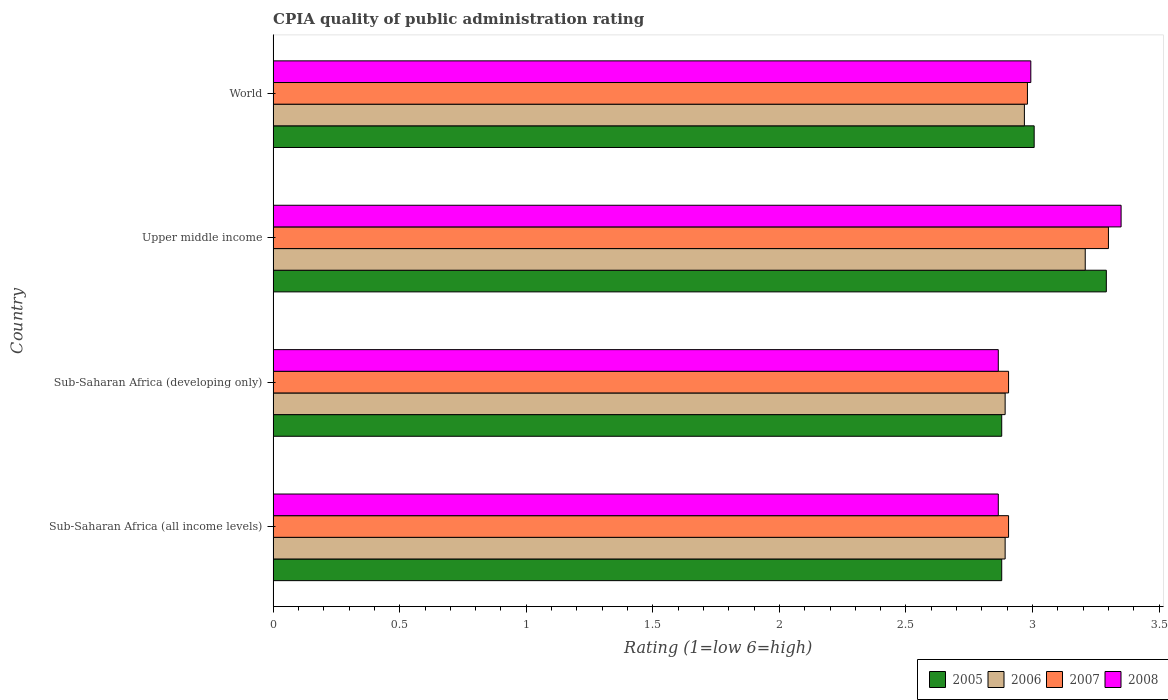How many different coloured bars are there?
Give a very brief answer. 4. How many groups of bars are there?
Keep it short and to the point. 4. Are the number of bars on each tick of the Y-axis equal?
Offer a very short reply. Yes. What is the label of the 3rd group of bars from the top?
Offer a very short reply. Sub-Saharan Africa (developing only). In how many cases, is the number of bars for a given country not equal to the number of legend labels?
Make the answer very short. 0. What is the CPIA rating in 2005 in World?
Your answer should be very brief. 3.01. Across all countries, what is the maximum CPIA rating in 2008?
Give a very brief answer. 3.35. Across all countries, what is the minimum CPIA rating in 2007?
Provide a succinct answer. 2.91. In which country was the CPIA rating in 2008 maximum?
Your response must be concise. Upper middle income. In which country was the CPIA rating in 2008 minimum?
Your answer should be very brief. Sub-Saharan Africa (all income levels). What is the total CPIA rating in 2008 in the graph?
Offer a very short reply. 12.07. What is the difference between the CPIA rating in 2005 in Upper middle income and that in World?
Your response must be concise. 0.29. What is the difference between the CPIA rating in 2008 in Sub-Saharan Africa (all income levels) and the CPIA rating in 2007 in Upper middle income?
Offer a very short reply. -0.44. What is the average CPIA rating in 2005 per country?
Your answer should be very brief. 3.01. What is the difference between the CPIA rating in 2005 and CPIA rating in 2008 in World?
Offer a terse response. 0.01. In how many countries, is the CPIA rating in 2006 greater than 2.4 ?
Provide a succinct answer. 4. What is the ratio of the CPIA rating in 2005 in Sub-Saharan Africa (developing only) to that in Upper middle income?
Offer a terse response. 0.87. Is the difference between the CPIA rating in 2005 in Sub-Saharan Africa (all income levels) and World greater than the difference between the CPIA rating in 2008 in Sub-Saharan Africa (all income levels) and World?
Make the answer very short. Yes. What is the difference between the highest and the second highest CPIA rating in 2008?
Make the answer very short. 0.36. What is the difference between the highest and the lowest CPIA rating in 2005?
Offer a terse response. 0.41. Is the sum of the CPIA rating in 2006 in Sub-Saharan Africa (all income levels) and Sub-Saharan Africa (developing only) greater than the maximum CPIA rating in 2007 across all countries?
Make the answer very short. Yes. Is it the case that in every country, the sum of the CPIA rating in 2008 and CPIA rating in 2005 is greater than the CPIA rating in 2007?
Give a very brief answer. Yes. Are all the bars in the graph horizontal?
Make the answer very short. Yes. What is the difference between two consecutive major ticks on the X-axis?
Offer a very short reply. 0.5. Are the values on the major ticks of X-axis written in scientific E-notation?
Offer a very short reply. No. Does the graph contain grids?
Give a very brief answer. No. Where does the legend appear in the graph?
Your response must be concise. Bottom right. What is the title of the graph?
Offer a very short reply. CPIA quality of public administration rating. What is the label or title of the X-axis?
Offer a very short reply. Rating (1=low 6=high). What is the label or title of the Y-axis?
Your response must be concise. Country. What is the Rating (1=low 6=high) of 2005 in Sub-Saharan Africa (all income levels)?
Keep it short and to the point. 2.88. What is the Rating (1=low 6=high) in 2006 in Sub-Saharan Africa (all income levels)?
Your answer should be compact. 2.89. What is the Rating (1=low 6=high) in 2007 in Sub-Saharan Africa (all income levels)?
Ensure brevity in your answer.  2.91. What is the Rating (1=low 6=high) in 2008 in Sub-Saharan Africa (all income levels)?
Make the answer very short. 2.86. What is the Rating (1=low 6=high) in 2005 in Sub-Saharan Africa (developing only)?
Provide a succinct answer. 2.88. What is the Rating (1=low 6=high) of 2006 in Sub-Saharan Africa (developing only)?
Offer a very short reply. 2.89. What is the Rating (1=low 6=high) of 2007 in Sub-Saharan Africa (developing only)?
Ensure brevity in your answer.  2.91. What is the Rating (1=low 6=high) of 2008 in Sub-Saharan Africa (developing only)?
Offer a very short reply. 2.86. What is the Rating (1=low 6=high) in 2005 in Upper middle income?
Provide a succinct answer. 3.29. What is the Rating (1=low 6=high) of 2006 in Upper middle income?
Keep it short and to the point. 3.21. What is the Rating (1=low 6=high) in 2007 in Upper middle income?
Keep it short and to the point. 3.3. What is the Rating (1=low 6=high) of 2008 in Upper middle income?
Offer a terse response. 3.35. What is the Rating (1=low 6=high) in 2005 in World?
Make the answer very short. 3.01. What is the Rating (1=low 6=high) in 2006 in World?
Your response must be concise. 2.97. What is the Rating (1=low 6=high) of 2007 in World?
Keep it short and to the point. 2.98. What is the Rating (1=low 6=high) in 2008 in World?
Your answer should be compact. 2.99. Across all countries, what is the maximum Rating (1=low 6=high) in 2005?
Your response must be concise. 3.29. Across all countries, what is the maximum Rating (1=low 6=high) of 2006?
Keep it short and to the point. 3.21. Across all countries, what is the maximum Rating (1=low 6=high) in 2007?
Offer a terse response. 3.3. Across all countries, what is the maximum Rating (1=low 6=high) in 2008?
Your answer should be compact. 3.35. Across all countries, what is the minimum Rating (1=low 6=high) of 2005?
Offer a very short reply. 2.88. Across all countries, what is the minimum Rating (1=low 6=high) in 2006?
Provide a succinct answer. 2.89. Across all countries, what is the minimum Rating (1=low 6=high) of 2007?
Give a very brief answer. 2.91. Across all countries, what is the minimum Rating (1=low 6=high) in 2008?
Keep it short and to the point. 2.86. What is the total Rating (1=low 6=high) in 2005 in the graph?
Provide a short and direct response. 12.05. What is the total Rating (1=low 6=high) in 2006 in the graph?
Make the answer very short. 11.96. What is the total Rating (1=low 6=high) in 2007 in the graph?
Provide a short and direct response. 12.09. What is the total Rating (1=low 6=high) of 2008 in the graph?
Provide a succinct answer. 12.07. What is the difference between the Rating (1=low 6=high) of 2006 in Sub-Saharan Africa (all income levels) and that in Sub-Saharan Africa (developing only)?
Keep it short and to the point. 0. What is the difference between the Rating (1=low 6=high) in 2007 in Sub-Saharan Africa (all income levels) and that in Sub-Saharan Africa (developing only)?
Offer a very short reply. 0. What is the difference between the Rating (1=low 6=high) in 2005 in Sub-Saharan Africa (all income levels) and that in Upper middle income?
Your answer should be compact. -0.41. What is the difference between the Rating (1=low 6=high) in 2006 in Sub-Saharan Africa (all income levels) and that in Upper middle income?
Offer a very short reply. -0.32. What is the difference between the Rating (1=low 6=high) in 2007 in Sub-Saharan Africa (all income levels) and that in Upper middle income?
Provide a short and direct response. -0.39. What is the difference between the Rating (1=low 6=high) in 2008 in Sub-Saharan Africa (all income levels) and that in Upper middle income?
Provide a succinct answer. -0.49. What is the difference between the Rating (1=low 6=high) of 2005 in Sub-Saharan Africa (all income levels) and that in World?
Provide a succinct answer. -0.13. What is the difference between the Rating (1=low 6=high) in 2006 in Sub-Saharan Africa (all income levels) and that in World?
Your answer should be compact. -0.08. What is the difference between the Rating (1=low 6=high) of 2007 in Sub-Saharan Africa (all income levels) and that in World?
Your answer should be compact. -0.07. What is the difference between the Rating (1=low 6=high) of 2008 in Sub-Saharan Africa (all income levels) and that in World?
Your response must be concise. -0.13. What is the difference between the Rating (1=low 6=high) of 2005 in Sub-Saharan Africa (developing only) and that in Upper middle income?
Provide a short and direct response. -0.41. What is the difference between the Rating (1=low 6=high) in 2006 in Sub-Saharan Africa (developing only) and that in Upper middle income?
Provide a short and direct response. -0.32. What is the difference between the Rating (1=low 6=high) of 2007 in Sub-Saharan Africa (developing only) and that in Upper middle income?
Offer a very short reply. -0.39. What is the difference between the Rating (1=low 6=high) in 2008 in Sub-Saharan Africa (developing only) and that in Upper middle income?
Your answer should be very brief. -0.49. What is the difference between the Rating (1=low 6=high) of 2005 in Sub-Saharan Africa (developing only) and that in World?
Give a very brief answer. -0.13. What is the difference between the Rating (1=low 6=high) in 2006 in Sub-Saharan Africa (developing only) and that in World?
Provide a short and direct response. -0.08. What is the difference between the Rating (1=low 6=high) in 2007 in Sub-Saharan Africa (developing only) and that in World?
Your answer should be very brief. -0.07. What is the difference between the Rating (1=low 6=high) of 2008 in Sub-Saharan Africa (developing only) and that in World?
Offer a very short reply. -0.13. What is the difference between the Rating (1=low 6=high) in 2005 in Upper middle income and that in World?
Your response must be concise. 0.29. What is the difference between the Rating (1=low 6=high) in 2006 in Upper middle income and that in World?
Provide a short and direct response. 0.24. What is the difference between the Rating (1=low 6=high) of 2007 in Upper middle income and that in World?
Provide a succinct answer. 0.32. What is the difference between the Rating (1=low 6=high) of 2008 in Upper middle income and that in World?
Provide a short and direct response. 0.36. What is the difference between the Rating (1=low 6=high) of 2005 in Sub-Saharan Africa (all income levels) and the Rating (1=low 6=high) of 2006 in Sub-Saharan Africa (developing only)?
Your answer should be compact. -0.01. What is the difference between the Rating (1=low 6=high) of 2005 in Sub-Saharan Africa (all income levels) and the Rating (1=low 6=high) of 2007 in Sub-Saharan Africa (developing only)?
Keep it short and to the point. -0.03. What is the difference between the Rating (1=low 6=high) in 2005 in Sub-Saharan Africa (all income levels) and the Rating (1=low 6=high) in 2008 in Sub-Saharan Africa (developing only)?
Offer a very short reply. 0.01. What is the difference between the Rating (1=low 6=high) in 2006 in Sub-Saharan Africa (all income levels) and the Rating (1=low 6=high) in 2007 in Sub-Saharan Africa (developing only)?
Make the answer very short. -0.01. What is the difference between the Rating (1=low 6=high) in 2006 in Sub-Saharan Africa (all income levels) and the Rating (1=low 6=high) in 2008 in Sub-Saharan Africa (developing only)?
Keep it short and to the point. 0.03. What is the difference between the Rating (1=low 6=high) of 2007 in Sub-Saharan Africa (all income levels) and the Rating (1=low 6=high) of 2008 in Sub-Saharan Africa (developing only)?
Make the answer very short. 0.04. What is the difference between the Rating (1=low 6=high) of 2005 in Sub-Saharan Africa (all income levels) and the Rating (1=low 6=high) of 2006 in Upper middle income?
Make the answer very short. -0.33. What is the difference between the Rating (1=low 6=high) of 2005 in Sub-Saharan Africa (all income levels) and the Rating (1=low 6=high) of 2007 in Upper middle income?
Keep it short and to the point. -0.42. What is the difference between the Rating (1=low 6=high) in 2005 in Sub-Saharan Africa (all income levels) and the Rating (1=low 6=high) in 2008 in Upper middle income?
Offer a terse response. -0.47. What is the difference between the Rating (1=low 6=high) of 2006 in Sub-Saharan Africa (all income levels) and the Rating (1=low 6=high) of 2007 in Upper middle income?
Offer a very short reply. -0.41. What is the difference between the Rating (1=low 6=high) in 2006 in Sub-Saharan Africa (all income levels) and the Rating (1=low 6=high) in 2008 in Upper middle income?
Your answer should be very brief. -0.46. What is the difference between the Rating (1=low 6=high) in 2007 in Sub-Saharan Africa (all income levels) and the Rating (1=low 6=high) in 2008 in Upper middle income?
Provide a succinct answer. -0.44. What is the difference between the Rating (1=low 6=high) in 2005 in Sub-Saharan Africa (all income levels) and the Rating (1=low 6=high) in 2006 in World?
Your answer should be compact. -0.09. What is the difference between the Rating (1=low 6=high) of 2005 in Sub-Saharan Africa (all income levels) and the Rating (1=low 6=high) of 2007 in World?
Give a very brief answer. -0.1. What is the difference between the Rating (1=low 6=high) in 2005 in Sub-Saharan Africa (all income levels) and the Rating (1=low 6=high) in 2008 in World?
Provide a succinct answer. -0.12. What is the difference between the Rating (1=low 6=high) in 2006 in Sub-Saharan Africa (all income levels) and the Rating (1=low 6=high) in 2007 in World?
Give a very brief answer. -0.09. What is the difference between the Rating (1=low 6=high) of 2006 in Sub-Saharan Africa (all income levels) and the Rating (1=low 6=high) of 2008 in World?
Keep it short and to the point. -0.1. What is the difference between the Rating (1=low 6=high) of 2007 in Sub-Saharan Africa (all income levels) and the Rating (1=low 6=high) of 2008 in World?
Offer a very short reply. -0.09. What is the difference between the Rating (1=low 6=high) of 2005 in Sub-Saharan Africa (developing only) and the Rating (1=low 6=high) of 2006 in Upper middle income?
Your response must be concise. -0.33. What is the difference between the Rating (1=low 6=high) of 2005 in Sub-Saharan Africa (developing only) and the Rating (1=low 6=high) of 2007 in Upper middle income?
Keep it short and to the point. -0.42. What is the difference between the Rating (1=low 6=high) in 2005 in Sub-Saharan Africa (developing only) and the Rating (1=low 6=high) in 2008 in Upper middle income?
Provide a succinct answer. -0.47. What is the difference between the Rating (1=low 6=high) in 2006 in Sub-Saharan Africa (developing only) and the Rating (1=low 6=high) in 2007 in Upper middle income?
Keep it short and to the point. -0.41. What is the difference between the Rating (1=low 6=high) in 2006 in Sub-Saharan Africa (developing only) and the Rating (1=low 6=high) in 2008 in Upper middle income?
Your response must be concise. -0.46. What is the difference between the Rating (1=low 6=high) of 2007 in Sub-Saharan Africa (developing only) and the Rating (1=low 6=high) of 2008 in Upper middle income?
Offer a terse response. -0.44. What is the difference between the Rating (1=low 6=high) in 2005 in Sub-Saharan Africa (developing only) and the Rating (1=low 6=high) in 2006 in World?
Provide a short and direct response. -0.09. What is the difference between the Rating (1=low 6=high) in 2005 in Sub-Saharan Africa (developing only) and the Rating (1=low 6=high) in 2007 in World?
Offer a terse response. -0.1. What is the difference between the Rating (1=low 6=high) of 2005 in Sub-Saharan Africa (developing only) and the Rating (1=low 6=high) of 2008 in World?
Give a very brief answer. -0.12. What is the difference between the Rating (1=low 6=high) in 2006 in Sub-Saharan Africa (developing only) and the Rating (1=low 6=high) in 2007 in World?
Make the answer very short. -0.09. What is the difference between the Rating (1=low 6=high) in 2006 in Sub-Saharan Africa (developing only) and the Rating (1=low 6=high) in 2008 in World?
Make the answer very short. -0.1. What is the difference between the Rating (1=low 6=high) of 2007 in Sub-Saharan Africa (developing only) and the Rating (1=low 6=high) of 2008 in World?
Make the answer very short. -0.09. What is the difference between the Rating (1=low 6=high) in 2005 in Upper middle income and the Rating (1=low 6=high) in 2006 in World?
Offer a terse response. 0.32. What is the difference between the Rating (1=low 6=high) in 2005 in Upper middle income and the Rating (1=low 6=high) in 2007 in World?
Provide a short and direct response. 0.31. What is the difference between the Rating (1=low 6=high) in 2005 in Upper middle income and the Rating (1=low 6=high) in 2008 in World?
Give a very brief answer. 0.3. What is the difference between the Rating (1=low 6=high) in 2006 in Upper middle income and the Rating (1=low 6=high) in 2007 in World?
Your answer should be very brief. 0.23. What is the difference between the Rating (1=low 6=high) in 2006 in Upper middle income and the Rating (1=low 6=high) in 2008 in World?
Your response must be concise. 0.21. What is the difference between the Rating (1=low 6=high) of 2007 in Upper middle income and the Rating (1=low 6=high) of 2008 in World?
Your answer should be compact. 0.31. What is the average Rating (1=low 6=high) in 2005 per country?
Offer a terse response. 3.01. What is the average Rating (1=low 6=high) in 2006 per country?
Offer a terse response. 2.99. What is the average Rating (1=low 6=high) of 2007 per country?
Your answer should be very brief. 3.02. What is the average Rating (1=low 6=high) of 2008 per country?
Keep it short and to the point. 3.02. What is the difference between the Rating (1=low 6=high) in 2005 and Rating (1=low 6=high) in 2006 in Sub-Saharan Africa (all income levels)?
Your response must be concise. -0.01. What is the difference between the Rating (1=low 6=high) of 2005 and Rating (1=low 6=high) of 2007 in Sub-Saharan Africa (all income levels)?
Your answer should be very brief. -0.03. What is the difference between the Rating (1=low 6=high) in 2005 and Rating (1=low 6=high) in 2008 in Sub-Saharan Africa (all income levels)?
Offer a very short reply. 0.01. What is the difference between the Rating (1=low 6=high) in 2006 and Rating (1=low 6=high) in 2007 in Sub-Saharan Africa (all income levels)?
Your answer should be very brief. -0.01. What is the difference between the Rating (1=low 6=high) of 2006 and Rating (1=low 6=high) of 2008 in Sub-Saharan Africa (all income levels)?
Your response must be concise. 0.03. What is the difference between the Rating (1=low 6=high) in 2007 and Rating (1=low 6=high) in 2008 in Sub-Saharan Africa (all income levels)?
Ensure brevity in your answer.  0.04. What is the difference between the Rating (1=low 6=high) in 2005 and Rating (1=low 6=high) in 2006 in Sub-Saharan Africa (developing only)?
Ensure brevity in your answer.  -0.01. What is the difference between the Rating (1=low 6=high) of 2005 and Rating (1=low 6=high) of 2007 in Sub-Saharan Africa (developing only)?
Ensure brevity in your answer.  -0.03. What is the difference between the Rating (1=low 6=high) in 2005 and Rating (1=low 6=high) in 2008 in Sub-Saharan Africa (developing only)?
Provide a short and direct response. 0.01. What is the difference between the Rating (1=low 6=high) in 2006 and Rating (1=low 6=high) in 2007 in Sub-Saharan Africa (developing only)?
Give a very brief answer. -0.01. What is the difference between the Rating (1=low 6=high) of 2006 and Rating (1=low 6=high) of 2008 in Sub-Saharan Africa (developing only)?
Your response must be concise. 0.03. What is the difference between the Rating (1=low 6=high) in 2007 and Rating (1=low 6=high) in 2008 in Sub-Saharan Africa (developing only)?
Offer a terse response. 0.04. What is the difference between the Rating (1=low 6=high) of 2005 and Rating (1=low 6=high) of 2006 in Upper middle income?
Provide a short and direct response. 0.08. What is the difference between the Rating (1=low 6=high) of 2005 and Rating (1=low 6=high) of 2007 in Upper middle income?
Make the answer very short. -0.01. What is the difference between the Rating (1=low 6=high) of 2005 and Rating (1=low 6=high) of 2008 in Upper middle income?
Provide a succinct answer. -0.06. What is the difference between the Rating (1=low 6=high) in 2006 and Rating (1=low 6=high) in 2007 in Upper middle income?
Offer a terse response. -0.09. What is the difference between the Rating (1=low 6=high) in 2006 and Rating (1=low 6=high) in 2008 in Upper middle income?
Offer a terse response. -0.14. What is the difference between the Rating (1=low 6=high) of 2007 and Rating (1=low 6=high) of 2008 in Upper middle income?
Offer a terse response. -0.05. What is the difference between the Rating (1=low 6=high) of 2005 and Rating (1=low 6=high) of 2006 in World?
Make the answer very short. 0.04. What is the difference between the Rating (1=low 6=high) of 2005 and Rating (1=low 6=high) of 2007 in World?
Your answer should be compact. 0.03. What is the difference between the Rating (1=low 6=high) in 2005 and Rating (1=low 6=high) in 2008 in World?
Your answer should be compact. 0.01. What is the difference between the Rating (1=low 6=high) in 2006 and Rating (1=low 6=high) in 2007 in World?
Provide a succinct answer. -0.01. What is the difference between the Rating (1=low 6=high) of 2006 and Rating (1=low 6=high) of 2008 in World?
Offer a very short reply. -0.03. What is the difference between the Rating (1=low 6=high) of 2007 and Rating (1=low 6=high) of 2008 in World?
Keep it short and to the point. -0.01. What is the ratio of the Rating (1=low 6=high) of 2005 in Sub-Saharan Africa (all income levels) to that in Sub-Saharan Africa (developing only)?
Keep it short and to the point. 1. What is the ratio of the Rating (1=low 6=high) in 2005 in Sub-Saharan Africa (all income levels) to that in Upper middle income?
Your answer should be compact. 0.87. What is the ratio of the Rating (1=low 6=high) in 2006 in Sub-Saharan Africa (all income levels) to that in Upper middle income?
Provide a short and direct response. 0.9. What is the ratio of the Rating (1=low 6=high) of 2007 in Sub-Saharan Africa (all income levels) to that in Upper middle income?
Keep it short and to the point. 0.88. What is the ratio of the Rating (1=low 6=high) of 2008 in Sub-Saharan Africa (all income levels) to that in Upper middle income?
Offer a very short reply. 0.86. What is the ratio of the Rating (1=low 6=high) of 2005 in Sub-Saharan Africa (all income levels) to that in World?
Ensure brevity in your answer.  0.96. What is the ratio of the Rating (1=low 6=high) of 2006 in Sub-Saharan Africa (all income levels) to that in World?
Provide a short and direct response. 0.97. What is the ratio of the Rating (1=low 6=high) of 2007 in Sub-Saharan Africa (all income levels) to that in World?
Provide a short and direct response. 0.97. What is the ratio of the Rating (1=low 6=high) of 2008 in Sub-Saharan Africa (all income levels) to that in World?
Give a very brief answer. 0.96. What is the ratio of the Rating (1=low 6=high) in 2005 in Sub-Saharan Africa (developing only) to that in Upper middle income?
Your response must be concise. 0.87. What is the ratio of the Rating (1=low 6=high) in 2006 in Sub-Saharan Africa (developing only) to that in Upper middle income?
Ensure brevity in your answer.  0.9. What is the ratio of the Rating (1=low 6=high) of 2007 in Sub-Saharan Africa (developing only) to that in Upper middle income?
Make the answer very short. 0.88. What is the ratio of the Rating (1=low 6=high) in 2008 in Sub-Saharan Africa (developing only) to that in Upper middle income?
Provide a short and direct response. 0.86. What is the ratio of the Rating (1=low 6=high) of 2005 in Sub-Saharan Africa (developing only) to that in World?
Your answer should be very brief. 0.96. What is the ratio of the Rating (1=low 6=high) in 2006 in Sub-Saharan Africa (developing only) to that in World?
Offer a terse response. 0.97. What is the ratio of the Rating (1=low 6=high) in 2007 in Sub-Saharan Africa (developing only) to that in World?
Make the answer very short. 0.97. What is the ratio of the Rating (1=low 6=high) in 2008 in Sub-Saharan Africa (developing only) to that in World?
Your response must be concise. 0.96. What is the ratio of the Rating (1=low 6=high) of 2005 in Upper middle income to that in World?
Keep it short and to the point. 1.09. What is the ratio of the Rating (1=low 6=high) of 2006 in Upper middle income to that in World?
Ensure brevity in your answer.  1.08. What is the ratio of the Rating (1=low 6=high) of 2007 in Upper middle income to that in World?
Keep it short and to the point. 1.11. What is the ratio of the Rating (1=low 6=high) of 2008 in Upper middle income to that in World?
Keep it short and to the point. 1.12. What is the difference between the highest and the second highest Rating (1=low 6=high) in 2005?
Keep it short and to the point. 0.29. What is the difference between the highest and the second highest Rating (1=low 6=high) in 2006?
Provide a succinct answer. 0.24. What is the difference between the highest and the second highest Rating (1=low 6=high) of 2007?
Ensure brevity in your answer.  0.32. What is the difference between the highest and the second highest Rating (1=low 6=high) in 2008?
Keep it short and to the point. 0.36. What is the difference between the highest and the lowest Rating (1=low 6=high) of 2005?
Your answer should be compact. 0.41. What is the difference between the highest and the lowest Rating (1=low 6=high) in 2006?
Ensure brevity in your answer.  0.32. What is the difference between the highest and the lowest Rating (1=low 6=high) in 2007?
Ensure brevity in your answer.  0.39. What is the difference between the highest and the lowest Rating (1=low 6=high) of 2008?
Your answer should be very brief. 0.49. 